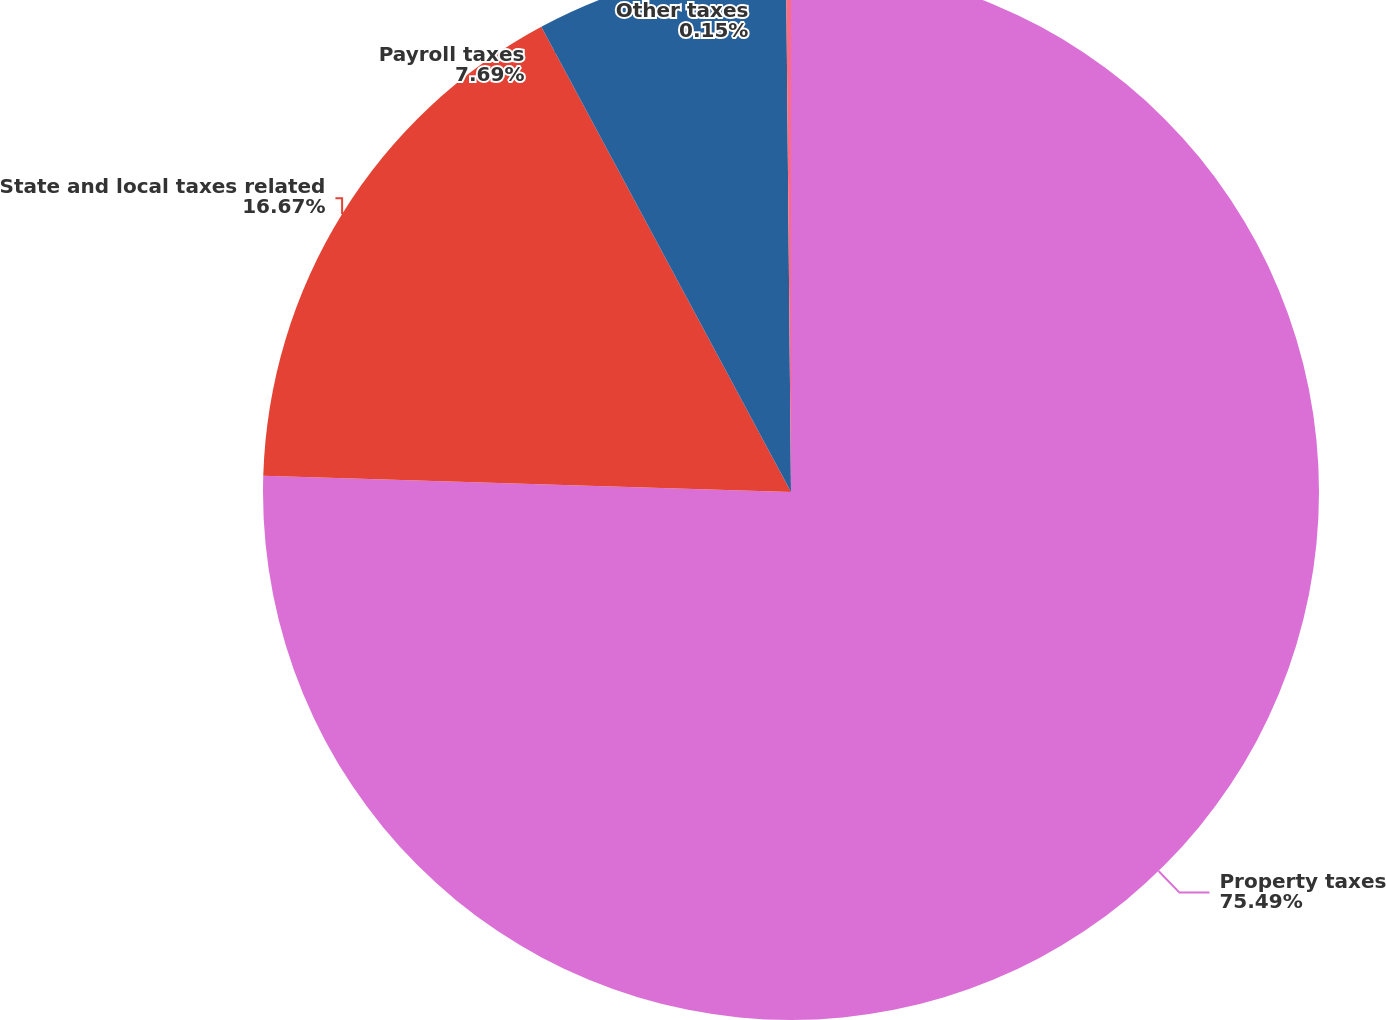Convert chart to OTSL. <chart><loc_0><loc_0><loc_500><loc_500><pie_chart><fcel>Property taxes<fcel>State and local taxes related<fcel>Payroll taxes<fcel>Other taxes<nl><fcel>75.49%<fcel>16.67%<fcel>7.69%<fcel>0.15%<nl></chart> 